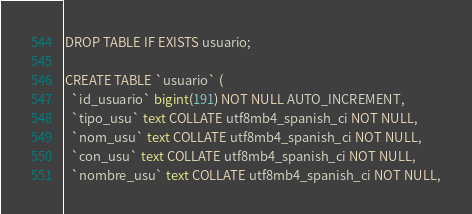Convert code to text. <code><loc_0><loc_0><loc_500><loc_500><_SQL_>DROP TABLE IF EXISTS usuario;

CREATE TABLE `usuario` (
  `id_usuario` bigint(191) NOT NULL AUTO_INCREMENT,
  `tipo_usu` text COLLATE utf8mb4_spanish_ci NOT NULL,
  `nom_usu` text COLLATE utf8mb4_spanish_ci NOT NULL,
  `con_usu` text COLLATE utf8mb4_spanish_ci NOT NULL,
  `nombre_usu` text COLLATE utf8mb4_spanish_ci NOT NULL,</code> 